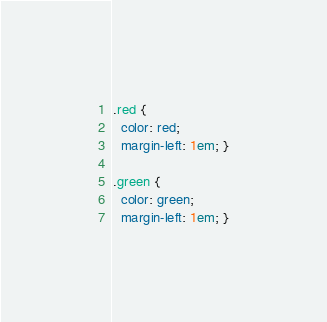Convert code to text. <code><loc_0><loc_0><loc_500><loc_500><_CSS_>.red {
  color: red;
  margin-left: 1em; }

.green {
  color: green;
  margin-left: 1em; }
</code> 